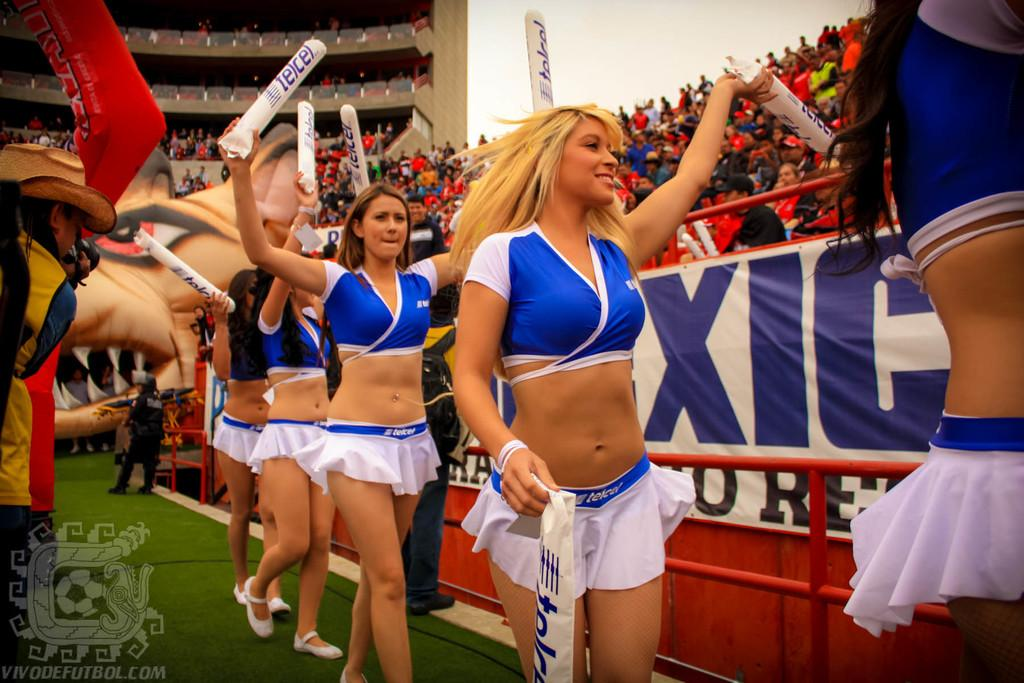<image>
Write a terse but informative summary of the picture. cheerleaders in blue and white holding white tubes with telcel on them 